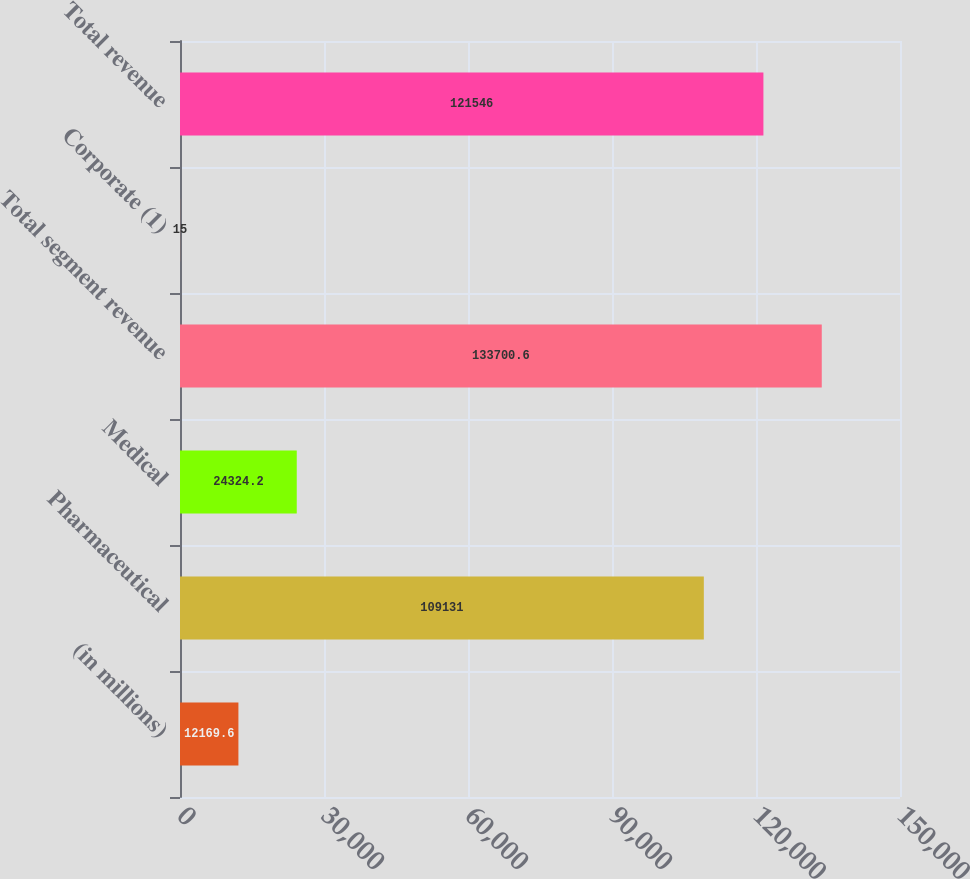Convert chart. <chart><loc_0><loc_0><loc_500><loc_500><bar_chart><fcel>(in millions)<fcel>Pharmaceutical<fcel>Medical<fcel>Total segment revenue<fcel>Corporate (1)<fcel>Total revenue<nl><fcel>12169.6<fcel>109131<fcel>24324.2<fcel>133701<fcel>15<fcel>121546<nl></chart> 